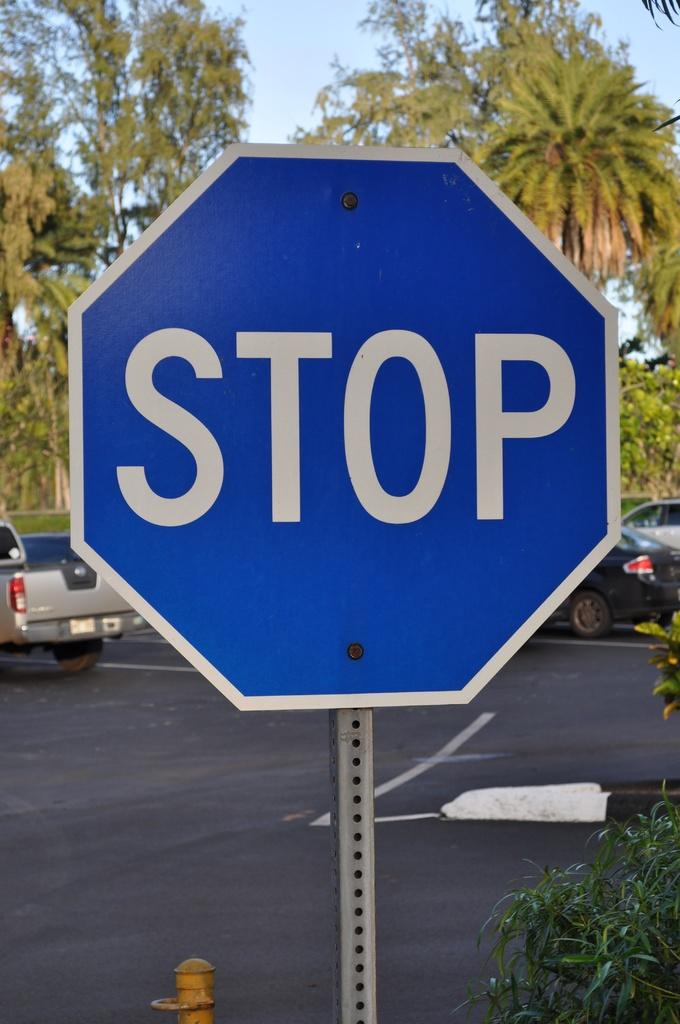<image>
Provide a brief description of the given image. A blue stop sign sits at the corner. 